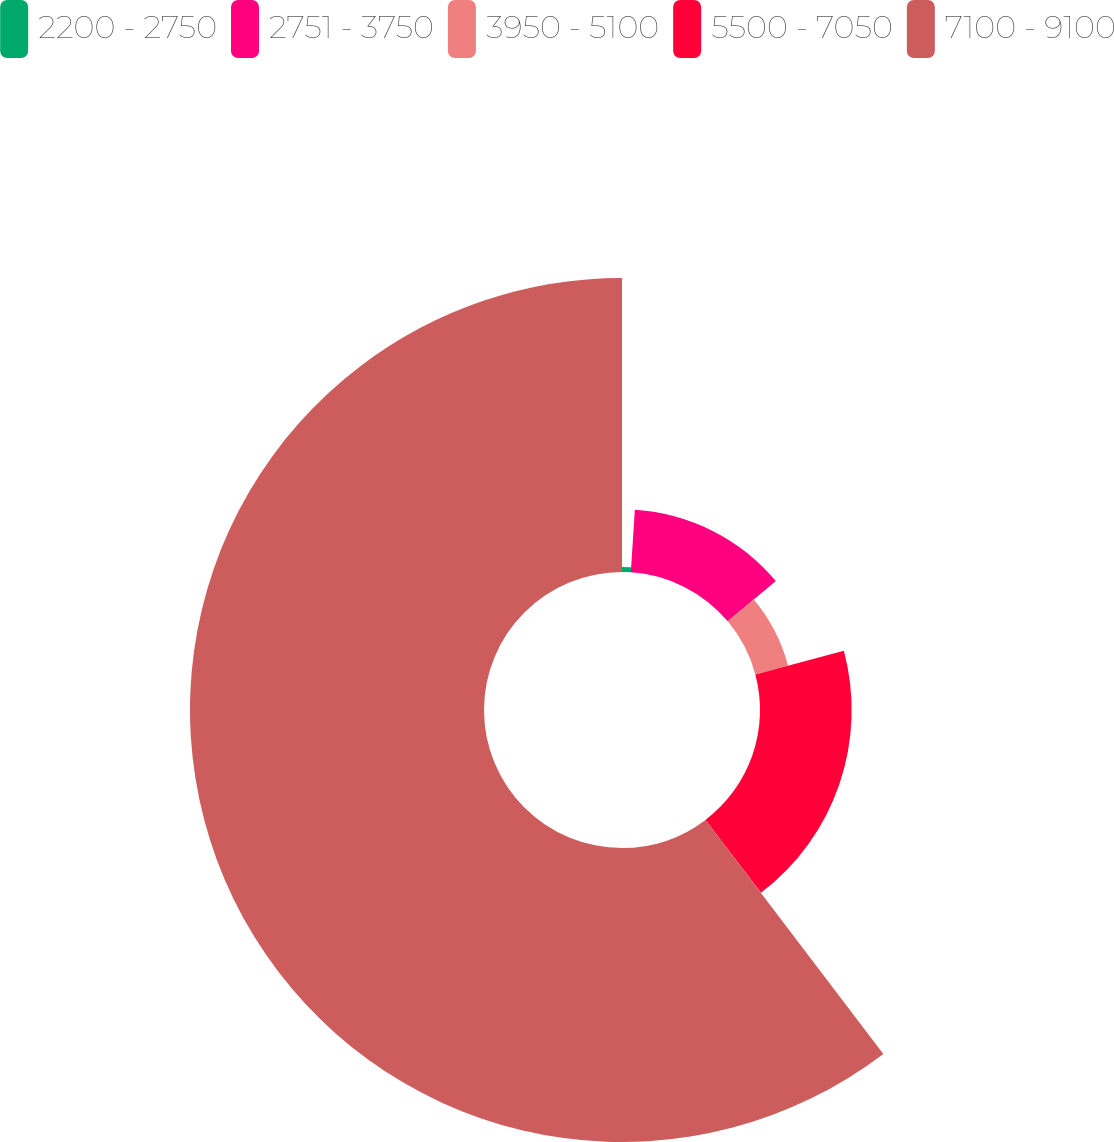Convert chart to OTSL. <chart><loc_0><loc_0><loc_500><loc_500><pie_chart><fcel>2200 - 2750<fcel>2751 - 3750<fcel>3950 - 5100<fcel>5500 - 7050<fcel>7100 - 9100<nl><fcel>1.02%<fcel>12.88%<fcel>6.95%<fcel>18.81%<fcel>60.34%<nl></chart> 